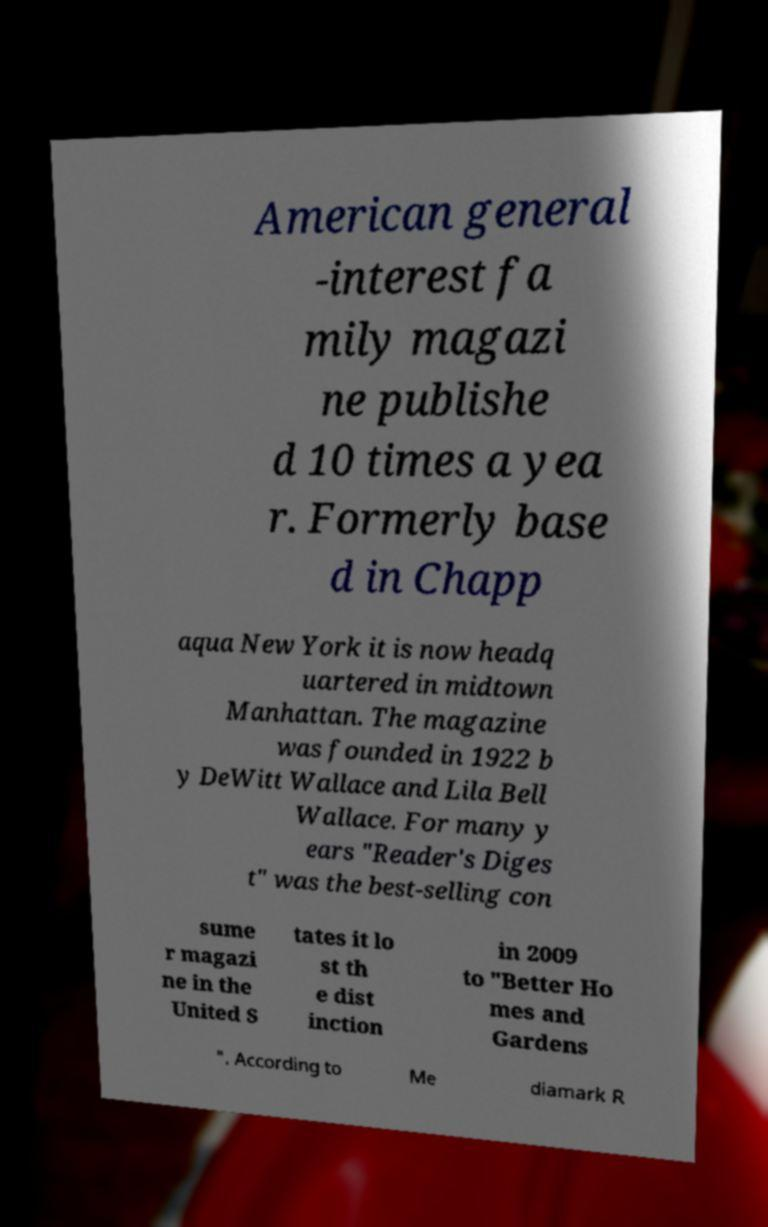Please identify and transcribe the text found in this image. American general -interest fa mily magazi ne publishe d 10 times a yea r. Formerly base d in Chapp aqua New York it is now headq uartered in midtown Manhattan. The magazine was founded in 1922 b y DeWitt Wallace and Lila Bell Wallace. For many y ears "Reader's Diges t" was the best-selling con sume r magazi ne in the United S tates it lo st th e dist inction in 2009 to "Better Ho mes and Gardens ". According to Me diamark R 